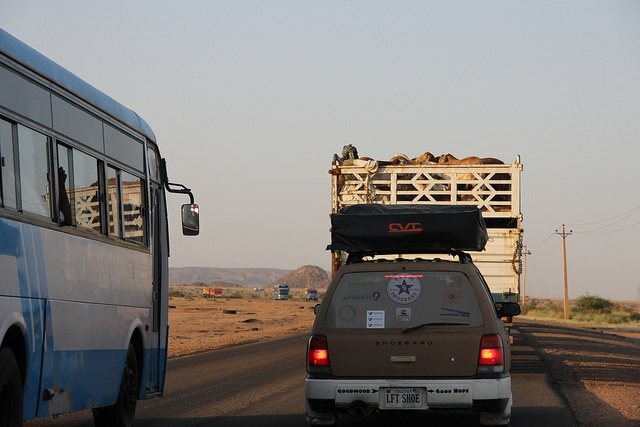Describe the objects in this image and their specific colors. I can see bus in darkgray, gray, black, and navy tones, car in darkgray, black, and gray tones, truck in darkgray, tan, and black tones, and car in darkgray, gray, and black tones in this image. 